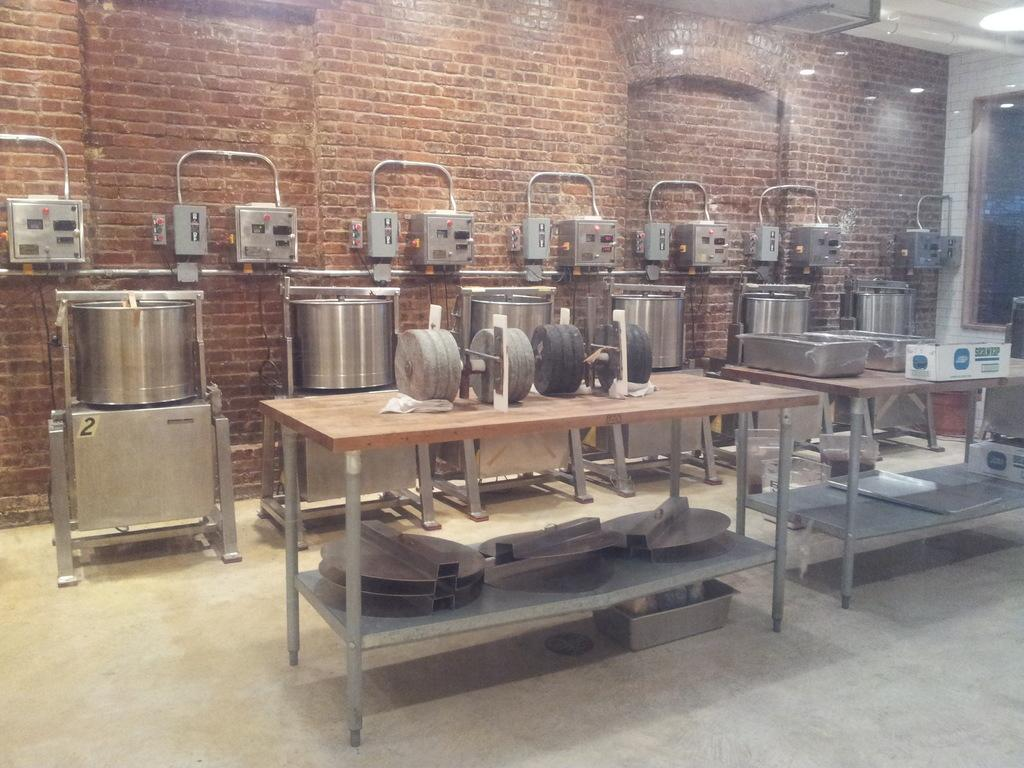What type of objects can be seen in the image that are related to technology? There are electronic devices in the image. What material are the containers/objects made of in the image? The containers/objects in the image are made of steel. What type of wall is visible in the image? There is a brick wall in the image. What are the roller stones used for, and where are they located in the image? The compact roller stones are located on a wooden table in the image, and they are likely used for grinding or polishing. What type of nail is being hammered into the coal in the image? There is no nail or coal present in the image; it features electronic devices, steel containers, a brick wall, and compact roller stones on a wooden table. 